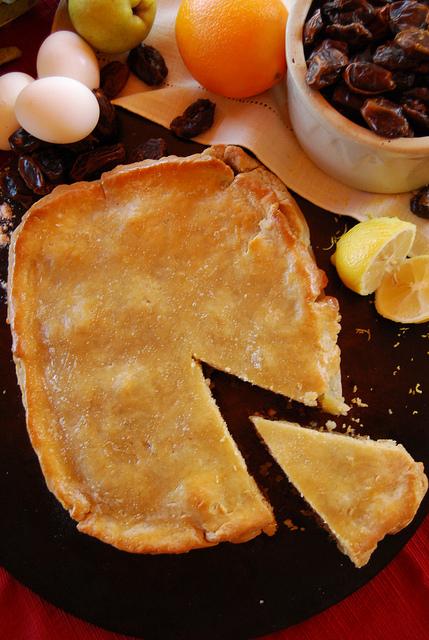Is this a pizza or a dessert?
Concise answer only. Dessert. How many eggs are in the picture?
Keep it brief. 3. How many oranges are there?
Short answer required. 1. What object is this?
Keep it brief. Pie. 